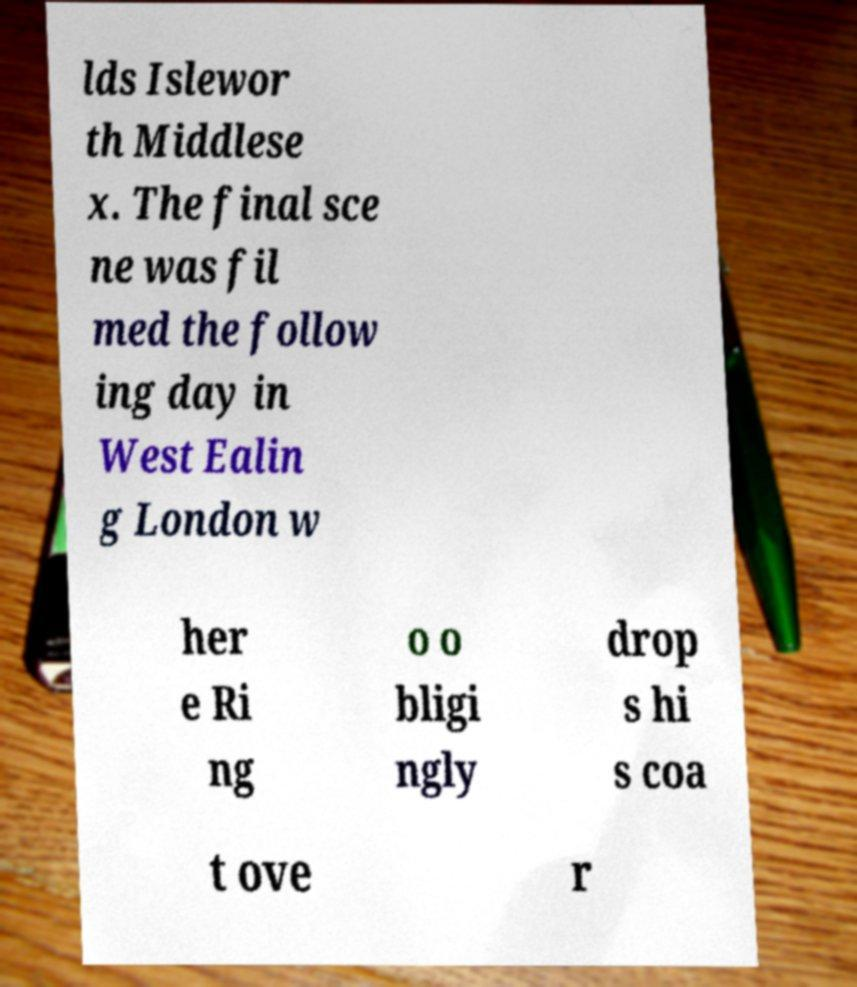Could you assist in decoding the text presented in this image and type it out clearly? lds Islewor th Middlese x. The final sce ne was fil med the follow ing day in West Ealin g London w her e Ri ng o o bligi ngly drop s hi s coa t ove r 